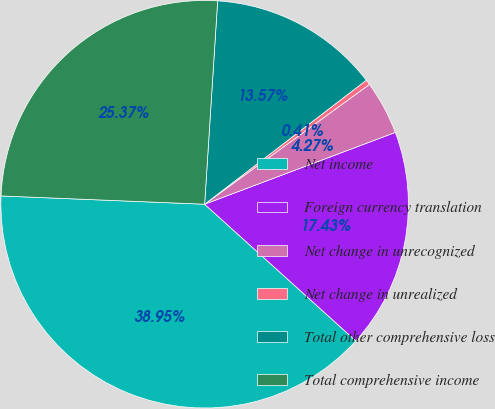Convert chart. <chart><loc_0><loc_0><loc_500><loc_500><pie_chart><fcel>Net income<fcel>Foreign currency translation<fcel>Net change in unrecognized<fcel>Net change in unrealized<fcel>Total other comprehensive loss<fcel>Total comprehensive income<nl><fcel>38.95%<fcel>17.43%<fcel>4.27%<fcel>0.41%<fcel>13.57%<fcel>25.37%<nl></chart> 